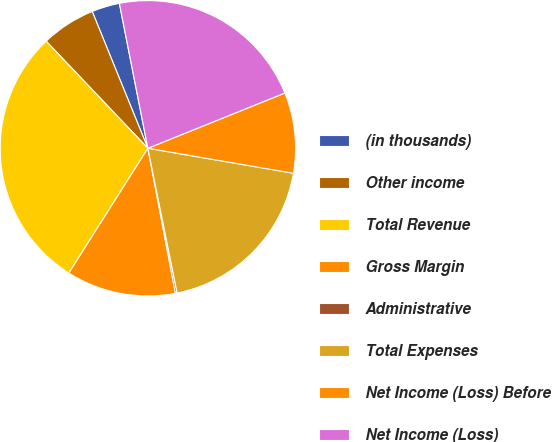<chart> <loc_0><loc_0><loc_500><loc_500><pie_chart><fcel>(in thousands)<fcel>Other income<fcel>Total Revenue<fcel>Gross Margin<fcel>Administrative<fcel>Total Expenses<fcel>Net Income (Loss) Before<fcel>Net Income (Loss)<nl><fcel>3.06%<fcel>5.94%<fcel>28.93%<fcel>11.97%<fcel>0.19%<fcel>19.12%<fcel>8.81%<fcel>21.99%<nl></chart> 